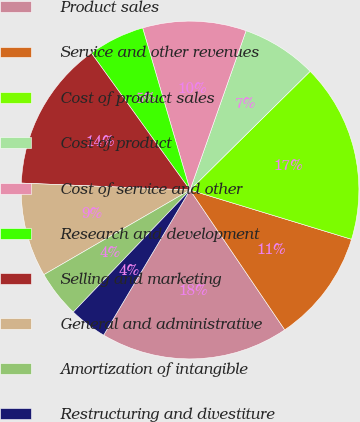<chart> <loc_0><loc_0><loc_500><loc_500><pie_chart><fcel>Product sales<fcel>Service and other revenues<fcel>Cost of product sales<fcel>Cost of product<fcel>Cost of service and other<fcel>Research and development<fcel>Selling and marketing<fcel>General and administrative<fcel>Amortization of intangible<fcel>Restructuring and divestiture<nl><fcel>18.02%<fcel>10.81%<fcel>17.12%<fcel>7.21%<fcel>9.91%<fcel>5.41%<fcel>14.41%<fcel>9.01%<fcel>4.5%<fcel>3.6%<nl></chart> 